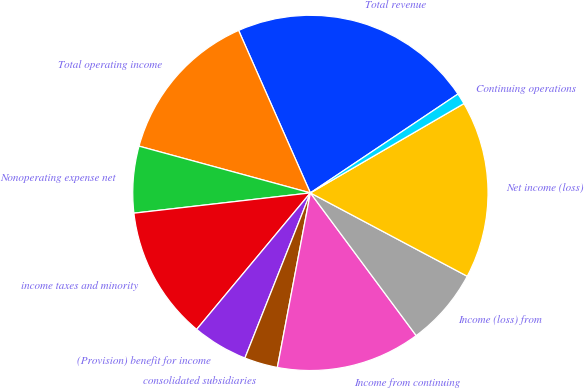<chart> <loc_0><loc_0><loc_500><loc_500><pie_chart><fcel>Total revenue<fcel>Total operating income<fcel>Nonoperating expense net<fcel>income taxes and minority<fcel>(Provision) benefit for income<fcel>consolidated subsidiaries<fcel>Income from continuing<fcel>Income (loss) from<fcel>Net income (loss)<fcel>Continuing operations<nl><fcel>22.22%<fcel>14.14%<fcel>6.06%<fcel>12.12%<fcel>5.05%<fcel>3.03%<fcel>13.13%<fcel>7.07%<fcel>16.16%<fcel>1.01%<nl></chart> 